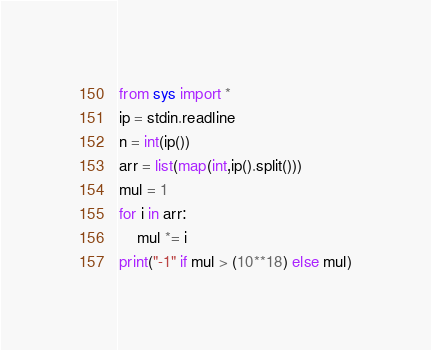Convert code to text. <code><loc_0><loc_0><loc_500><loc_500><_Python_>from sys import *
ip = stdin.readline
n = int(ip())
arr = list(map(int,ip().split()))
mul = 1
for i in arr:
    mul *= i
print("-1" if mul > (10**18) else mul)</code> 